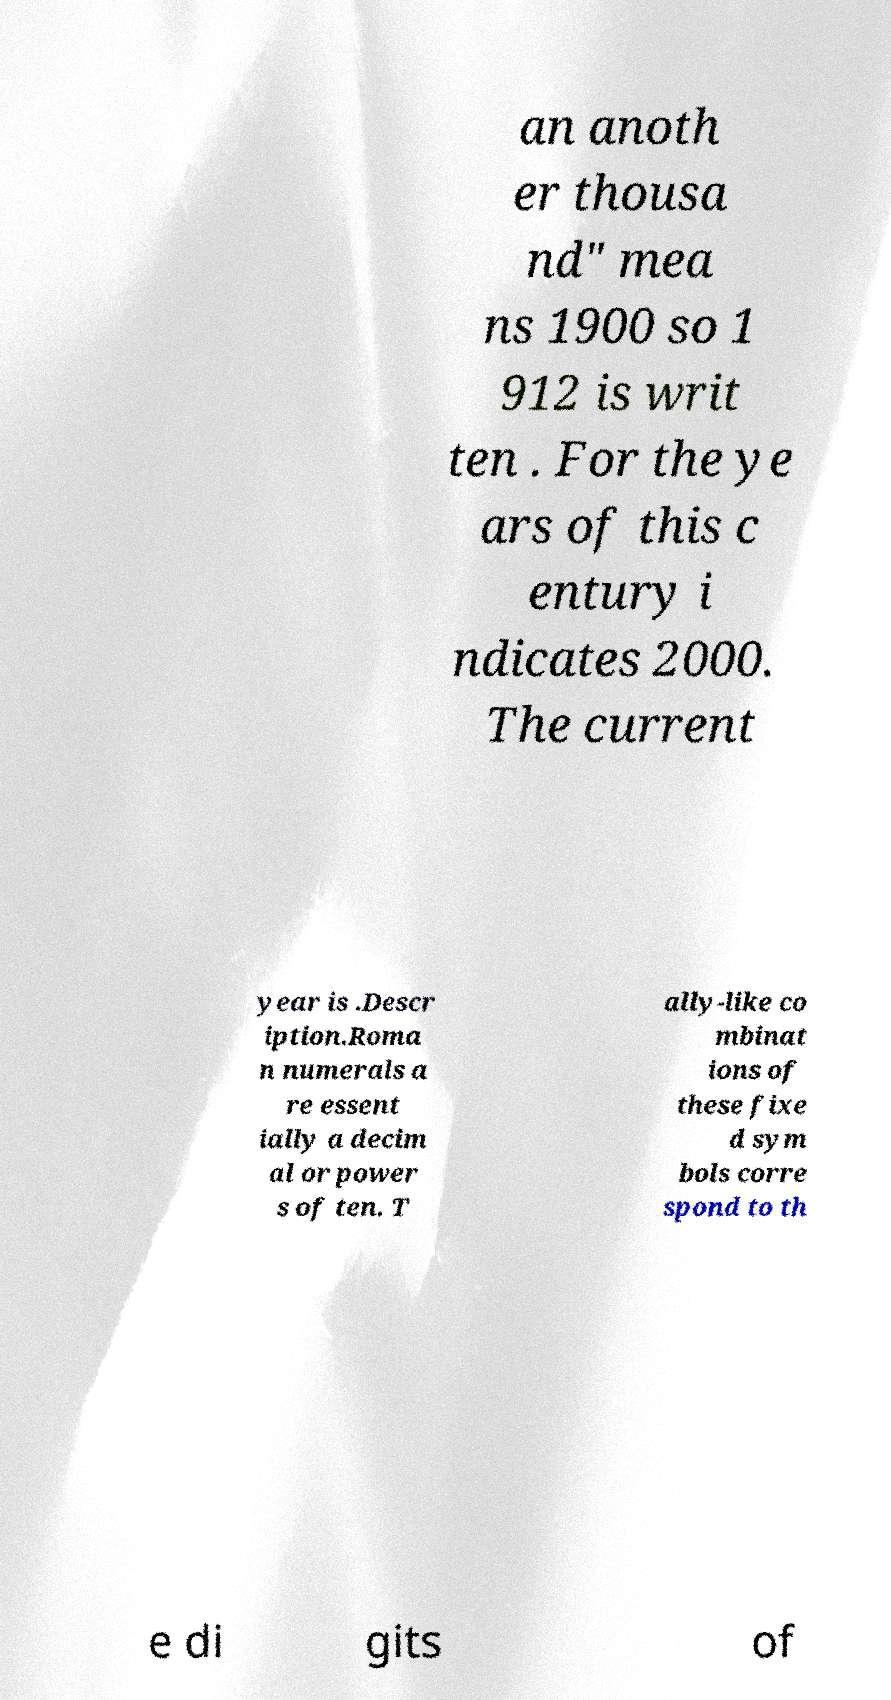Can you accurately transcribe the text from the provided image for me? an anoth er thousa nd" mea ns 1900 so 1 912 is writ ten . For the ye ars of this c entury i ndicates 2000. The current year is .Descr iption.Roma n numerals a re essent ially a decim al or power s of ten. T ally-like co mbinat ions of these fixe d sym bols corre spond to th e di gits of 